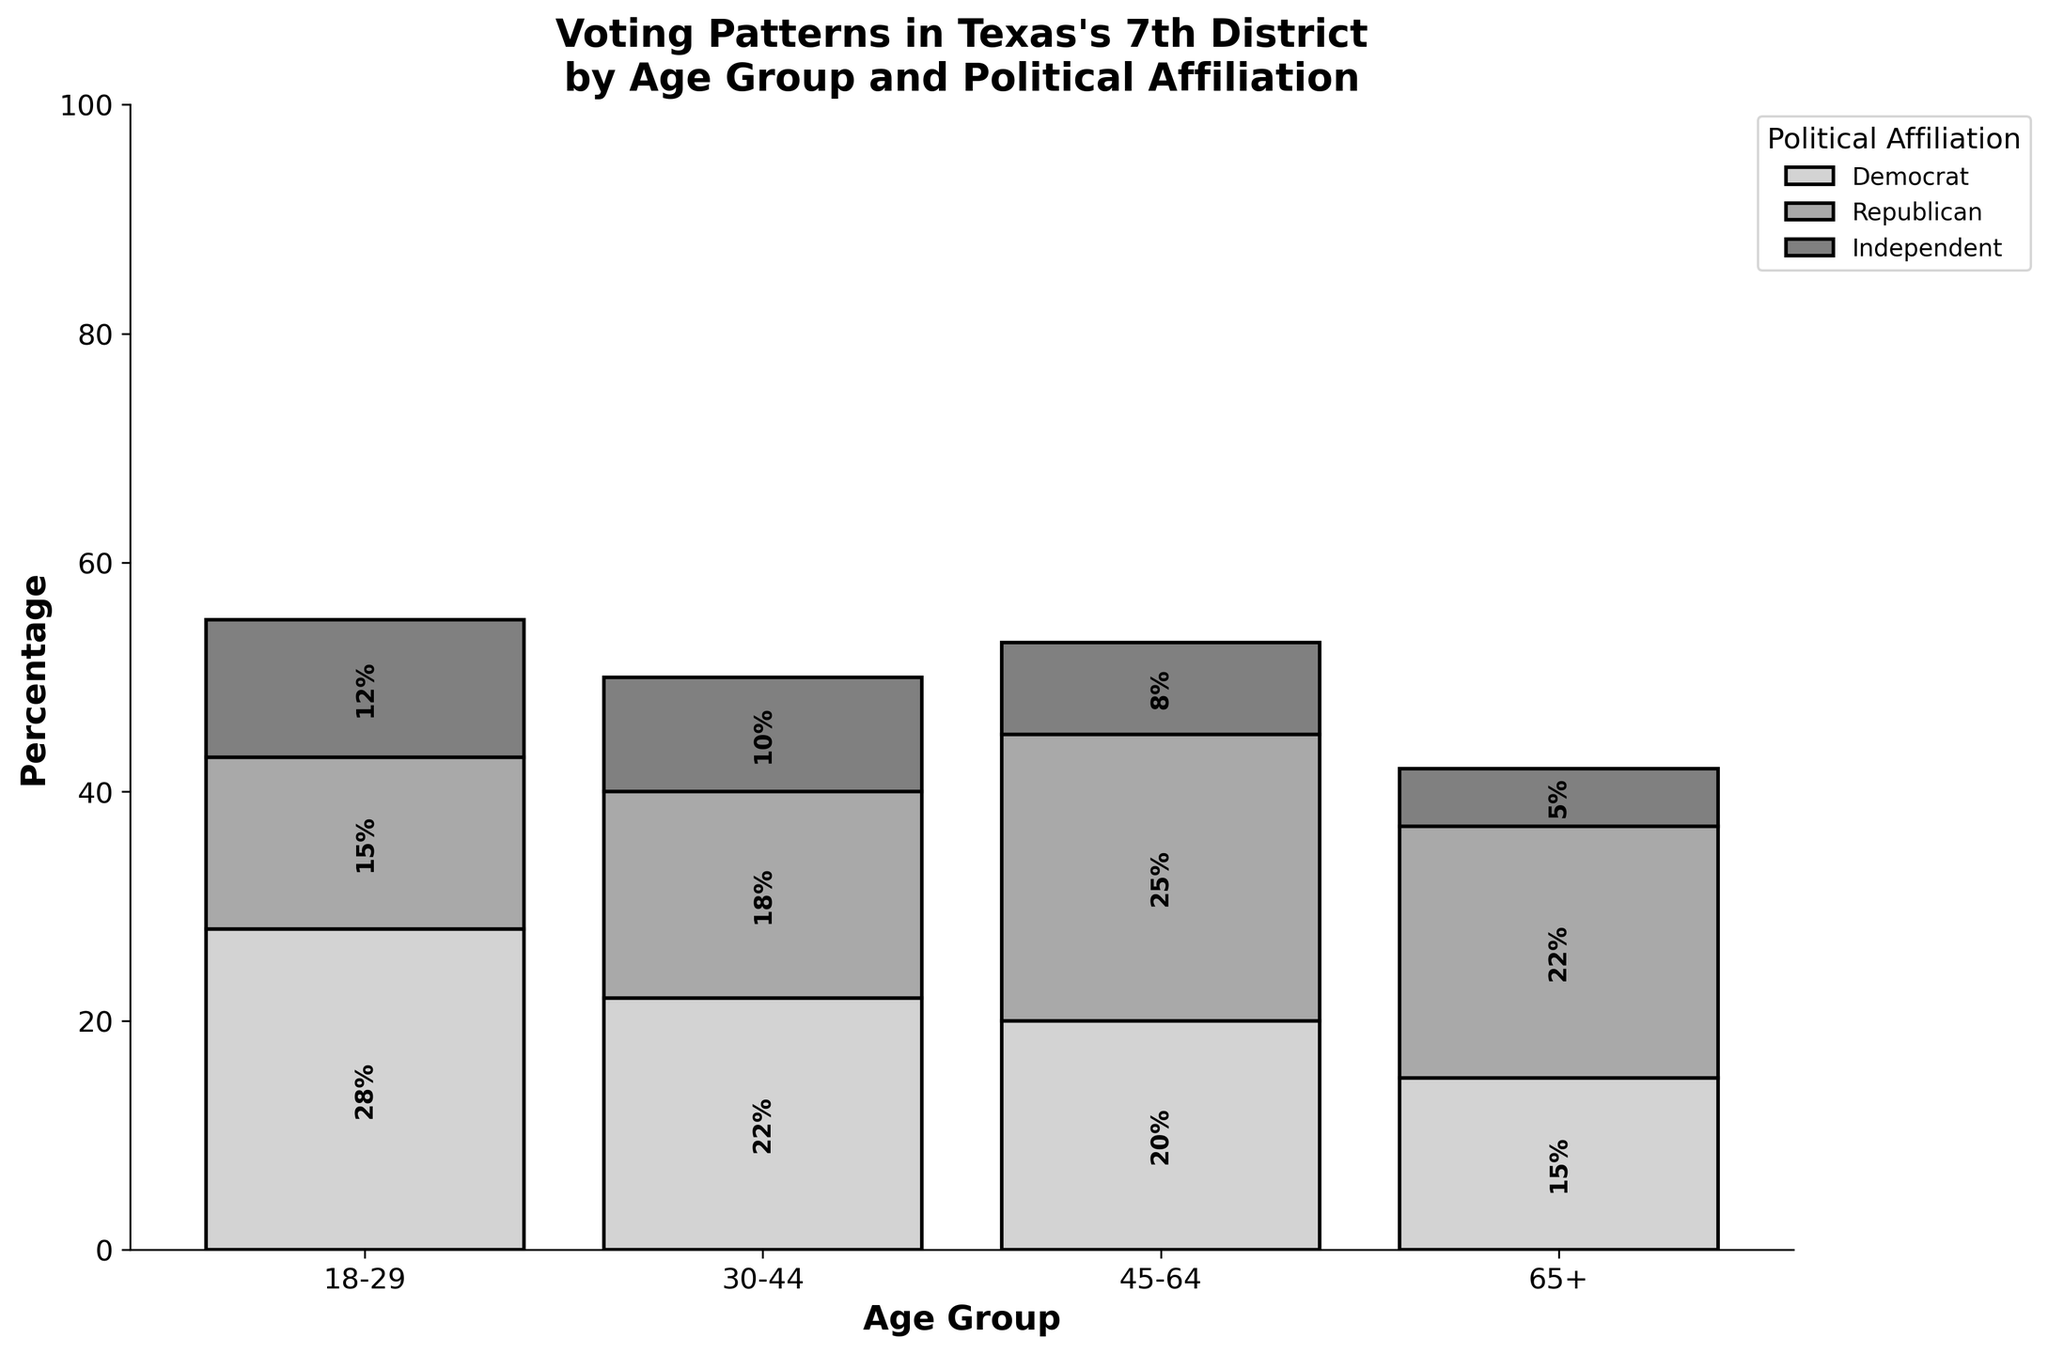Which age group has the highest percentage of Democrat voters? By examining the bars labeled "Democrat" in each age group, we see that the 18-29 age group has the tallest bar at 28%.
Answer: 18-29 What is the sum of the percentages for Republican voters across all age groups? Add the heights of the "Republican" bars in each age group: 15% (18-29) + 18% (30-44) + 25% (45-64) + 22% (65+) = 80%.
Answer: 80% In which age group is the percentage of Independent voters the lowest? Look at the "Independent" bars across all age groups and compare their heights. The 65+ age group has the lowest at 5%.
Answer: 65+ How do the percentages of Democrat voters compare between the 18-29 and 45-64 age groups? Compare the heights of the "Democrat" bars in the 18-29 and 45-64 age groups. The 18-29 group has 28%, while the 45-64 group has 20%. Thus, 18-29 has a higher percentage.
Answer: 18-29 What is the difference in percentage between Democrat and Republican voters in the 45-64 age group? Subtract the height of the "Republican" bar from the "Democrat" bar in the 45-64 age group: 25% (Republican) - 20% (Democrat) = 5%.
Answer: 5% Which political affiliation has the highest total percentage across all age groups? Sum the percentages for each political affiliation across all age groups and compare them:
- Democrat: 28% + 22% + 20% + 15% = 85%
- Republican: 15% + 18% + 25% + 22% = 80%
- Independent: 12% + 10% + 8% + 5% = 35%
Democrats have the highest total at 85%.
Answer: Democrat What is the total percentage of voters aged 30-44? Sum the heights of all bars in the 30-44 age group: 22% (Democrat) + 18% (Republican) + 10% (Independent) = 50%.
Answer: 50% How much higher is the percentage of Democrat voters in the 18-29 age group compared to the percentage of Independent voters in the same age group? Subtract the height of the "Independent" bar from the "Democrat" bar in the 18-29 age group: 28% (Democrat) - 12% (Independent) = 16%.
Answer: 16% Is there any age group where the percentage of voters is equally distributed among political affiliations? Look at the heights of all bars within each age group to see if they are equal. None of the age groups have equal percentages among Democrat, Republican, and Independent voters.
Answer: No What is the combined percentage of Democrat and Independent voters in the 65+ age group? Add the heights of the "Democrat" and "Independent" bars in the 65+ age group: 15% (Democrat) + 5% (Independent) = 20%.
Answer: 20% 